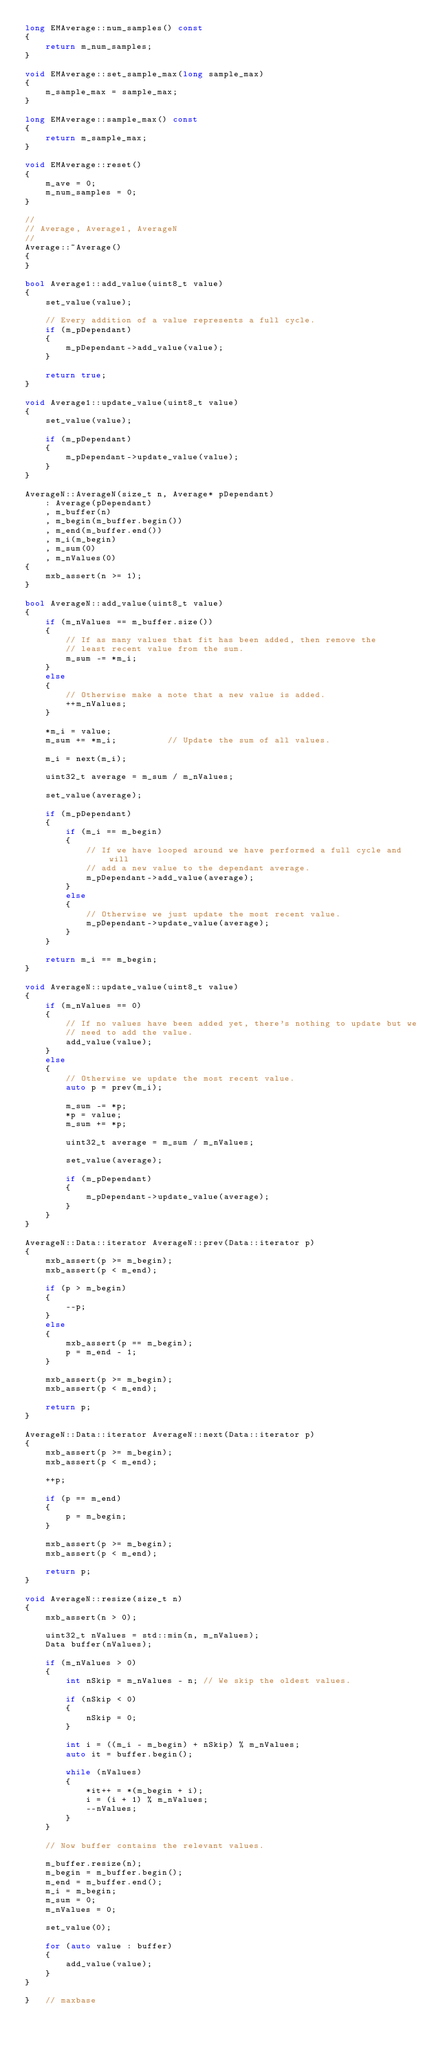<code> <loc_0><loc_0><loc_500><loc_500><_C++_>long EMAverage::num_samples() const
{
    return m_num_samples;
}

void EMAverage::set_sample_max(long sample_max)
{
    m_sample_max = sample_max;
}

long EMAverage::sample_max() const
{
    return m_sample_max;
}

void EMAverage::reset()
{
    m_ave = 0;
    m_num_samples = 0;
}

//
// Average, Average1, AverageN
//
Average::~Average()
{
}

bool Average1::add_value(uint8_t value)
{
    set_value(value);

    // Every addition of a value represents a full cycle.
    if (m_pDependant)
    {
        m_pDependant->add_value(value);
    }

    return true;
}

void Average1::update_value(uint8_t value)
{
    set_value(value);

    if (m_pDependant)
    {
        m_pDependant->update_value(value);
    }
}

AverageN::AverageN(size_t n, Average* pDependant)
    : Average(pDependant)
    , m_buffer(n)
    , m_begin(m_buffer.begin())
    , m_end(m_buffer.end())
    , m_i(m_begin)
    , m_sum(0)
    , m_nValues(0)
{
    mxb_assert(n >= 1);
}

bool AverageN::add_value(uint8_t value)
{
    if (m_nValues == m_buffer.size())
    {
        // If as many values that fit has been added, then remove the
        // least recent value from the sum.
        m_sum -= *m_i;
    }
    else
    {
        // Otherwise make a note that a new value is added.
        ++m_nValues;
    }

    *m_i = value;
    m_sum += *m_i;          // Update the sum of all values.

    m_i = next(m_i);

    uint32_t average = m_sum / m_nValues;

    set_value(average);

    if (m_pDependant)
    {
        if (m_i == m_begin)
        {
            // If we have looped around we have performed a full cycle and will
            // add a new value to the dependant average.
            m_pDependant->add_value(average);
        }
        else
        {
            // Otherwise we just update the most recent value.
            m_pDependant->update_value(average);
        }
    }

    return m_i == m_begin;
}

void AverageN::update_value(uint8_t value)
{
    if (m_nValues == 0)
    {
        // If no values have been added yet, there's nothing to update but we
        // need to add the value.
        add_value(value);
    }
    else
    {
        // Otherwise we update the most recent value.
        auto p = prev(m_i);

        m_sum -= *p;
        *p = value;
        m_sum += *p;

        uint32_t average = m_sum / m_nValues;

        set_value(average);

        if (m_pDependant)
        {
            m_pDependant->update_value(average);
        }
    }
}

AverageN::Data::iterator AverageN::prev(Data::iterator p)
{
    mxb_assert(p >= m_begin);
    mxb_assert(p < m_end);

    if (p > m_begin)
    {
        --p;
    }
    else
    {
        mxb_assert(p == m_begin);
        p = m_end - 1;
    }

    mxb_assert(p >= m_begin);
    mxb_assert(p < m_end);

    return p;
}

AverageN::Data::iterator AverageN::next(Data::iterator p)
{
    mxb_assert(p >= m_begin);
    mxb_assert(p < m_end);

    ++p;

    if (p == m_end)
    {
        p = m_begin;
    }

    mxb_assert(p >= m_begin);
    mxb_assert(p < m_end);

    return p;
}

void AverageN::resize(size_t n)
{
    mxb_assert(n > 0);

    uint32_t nValues = std::min(n, m_nValues);
    Data buffer(nValues);

    if (m_nValues > 0)
    {
        int nSkip = m_nValues - n; // We skip the oldest values.

        if (nSkip < 0)
        {
            nSkip = 0;
        }

        int i = ((m_i - m_begin) + nSkip) % m_nValues;
        auto it = buffer.begin();

        while (nValues)
        {
            *it++ = *(m_begin + i);
            i = (i + 1) % m_nValues;
            --nValues;
        }
    }

    // Now buffer contains the relevant values.

    m_buffer.resize(n);
    m_begin = m_buffer.begin();
    m_end = m_buffer.end();
    m_i = m_begin;
    m_sum = 0;
    m_nValues = 0;

    set_value(0);

    for (auto value : buffer)
    {
        add_value(value);
    }
}

}   // maxbase
</code> 